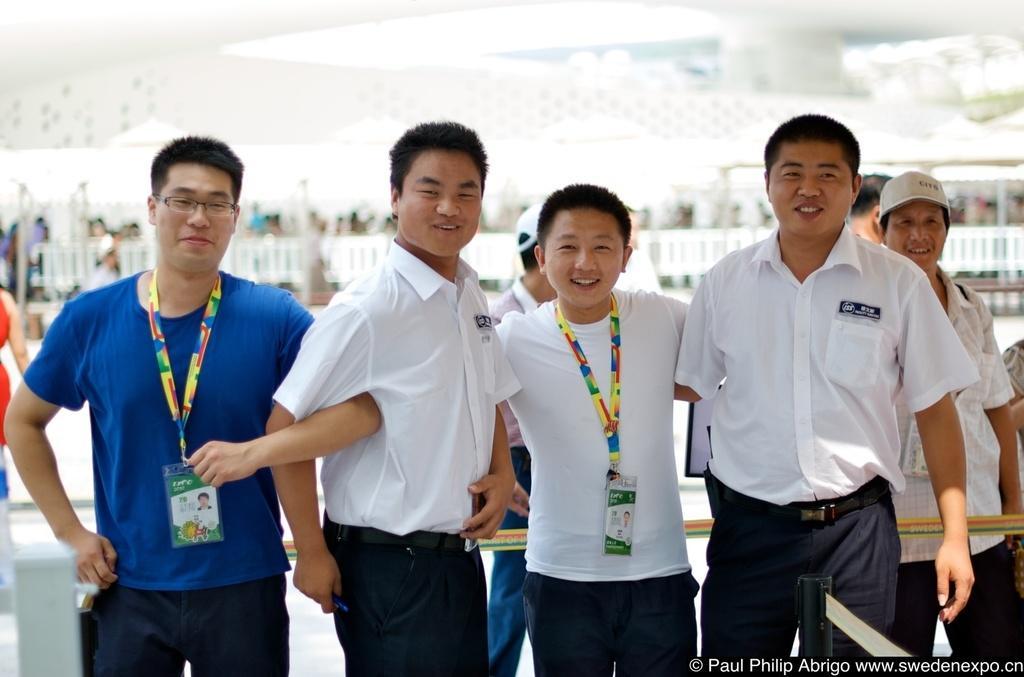How would you summarize this image in a sentence or two? In this image there are person standing, there are person wearing id cards, there is text towards the bottom of the image, there is an object truncated towards the right of the image, there is a person truncated towards the right of the image, there is a person truncated towards the left of the image, there is an object truncated towards the right of the image, there is a tent, there is a wooden fencing behind the persons, there is an object truncated towards the bottom of the image, the background of the image is blurred. 